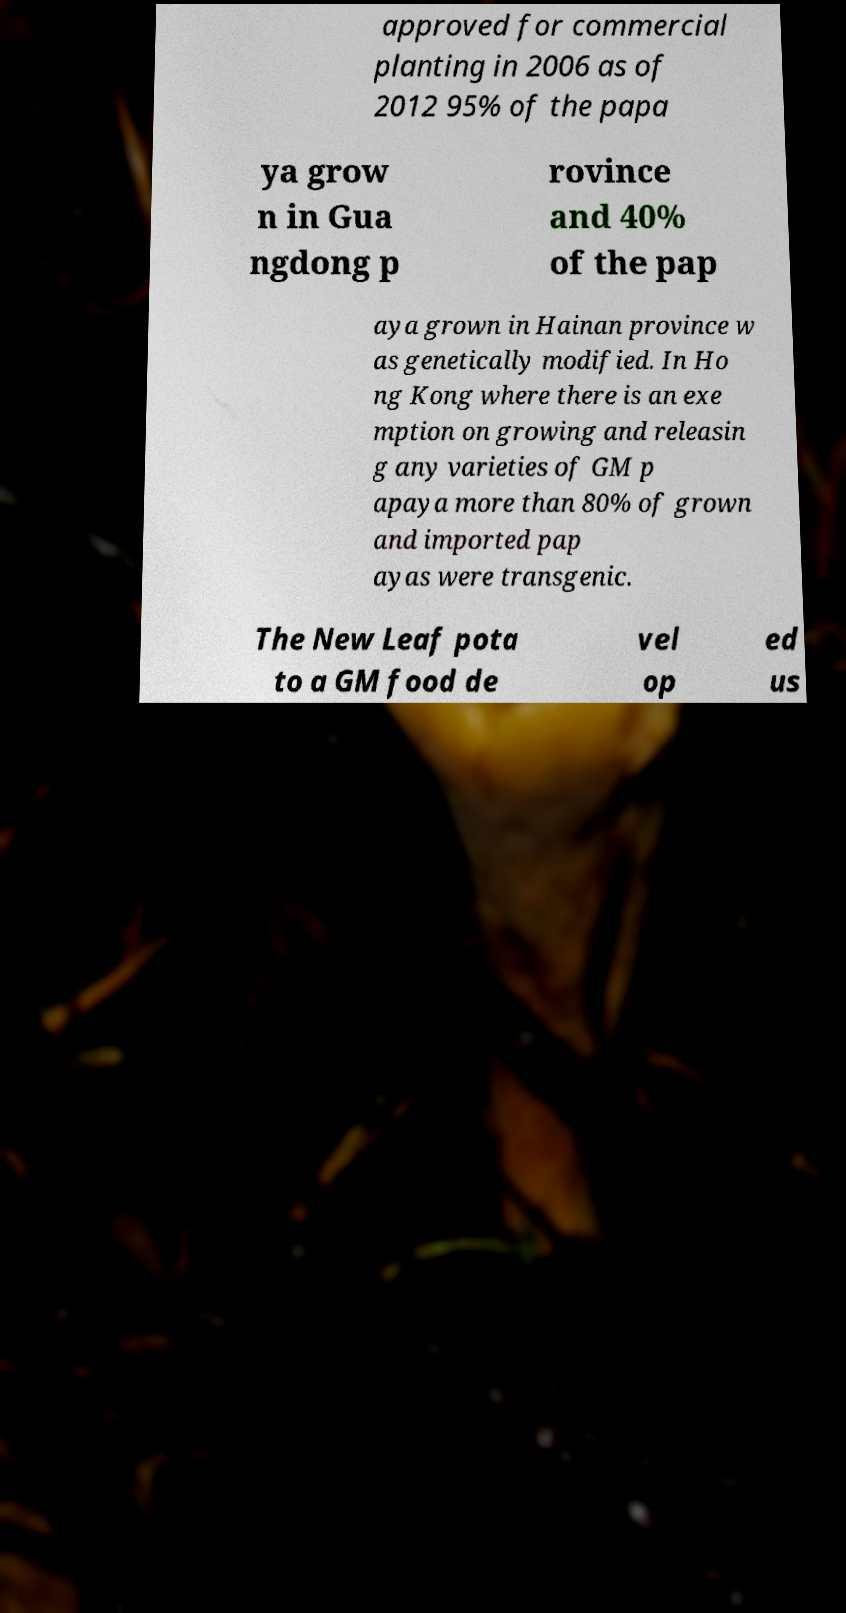Can you accurately transcribe the text from the provided image for me? approved for commercial planting in 2006 as of 2012 95% of the papa ya grow n in Gua ngdong p rovince and 40% of the pap aya grown in Hainan province w as genetically modified. In Ho ng Kong where there is an exe mption on growing and releasin g any varieties of GM p apaya more than 80% of grown and imported pap ayas were transgenic. The New Leaf pota to a GM food de vel op ed us 